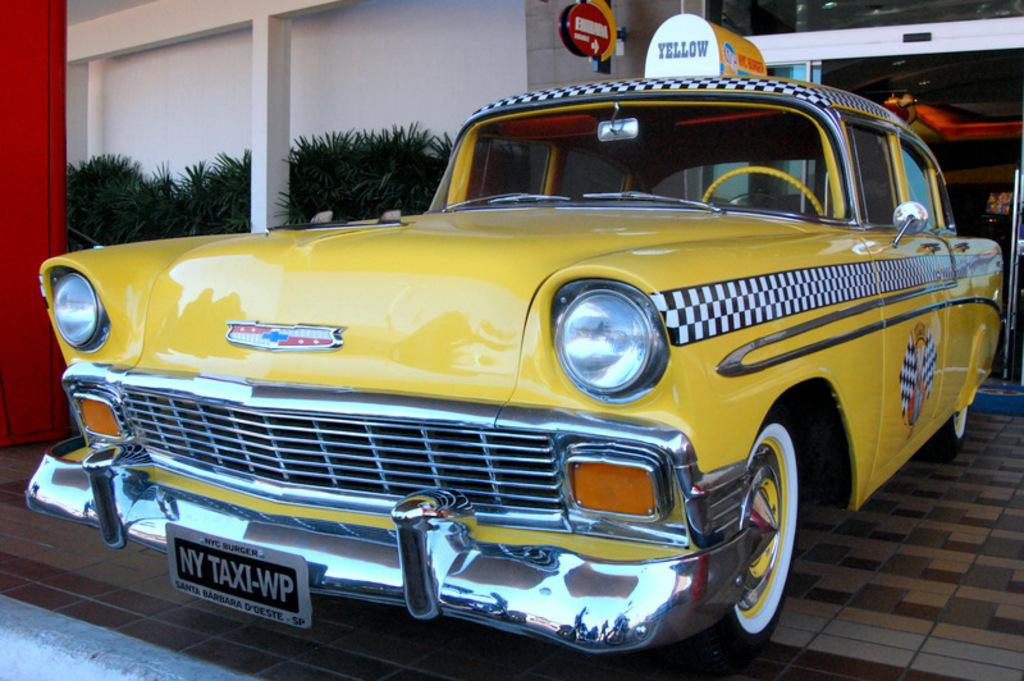<image>
Render a clear and concise summary of the photo. An old fashioned yellow taxi cab with black and white checkerboard from the fifties is parked on the sidewalk in front of a building. 